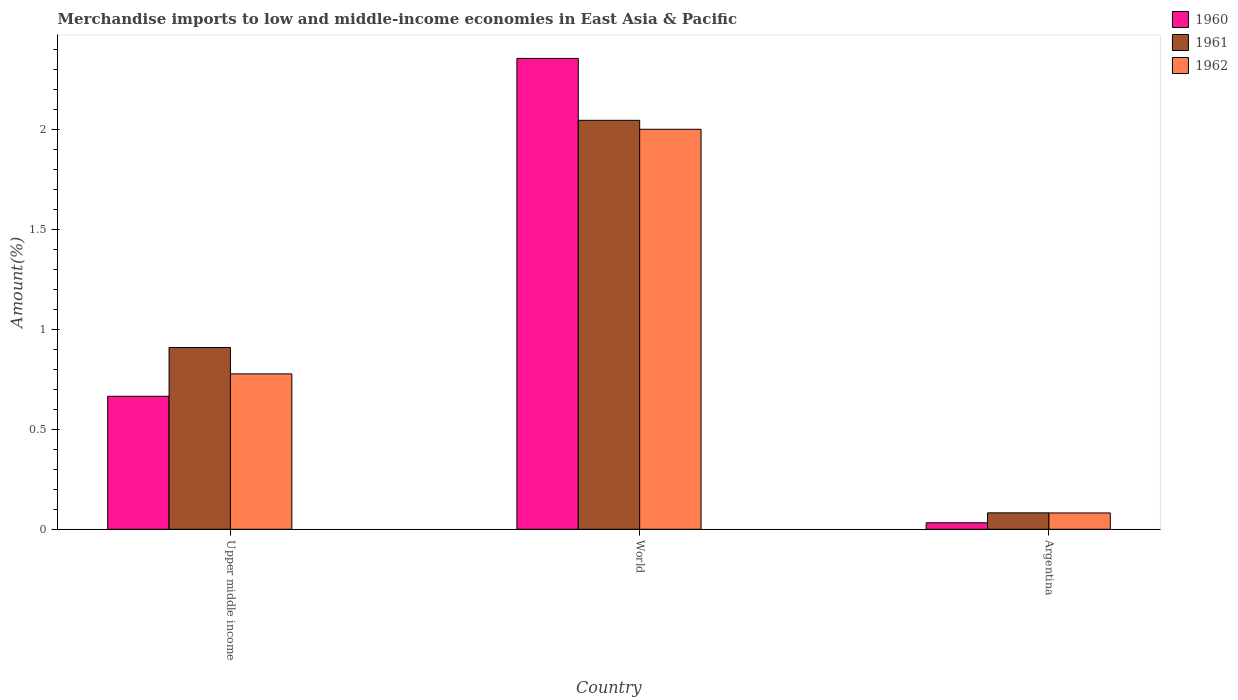How many groups of bars are there?
Provide a succinct answer. 3. Are the number of bars per tick equal to the number of legend labels?
Your answer should be very brief. Yes. What is the percentage of amount earned from merchandise imports in 1961 in World?
Keep it short and to the point. 2.05. Across all countries, what is the maximum percentage of amount earned from merchandise imports in 1961?
Ensure brevity in your answer.  2.05. Across all countries, what is the minimum percentage of amount earned from merchandise imports in 1960?
Provide a succinct answer. 0.03. In which country was the percentage of amount earned from merchandise imports in 1960 maximum?
Keep it short and to the point. World. What is the total percentage of amount earned from merchandise imports in 1960 in the graph?
Provide a succinct answer. 3.05. What is the difference between the percentage of amount earned from merchandise imports in 1961 in Argentina and that in World?
Offer a very short reply. -1.96. What is the difference between the percentage of amount earned from merchandise imports in 1960 in World and the percentage of amount earned from merchandise imports in 1961 in Argentina?
Your answer should be compact. 2.27. What is the average percentage of amount earned from merchandise imports in 1961 per country?
Your answer should be compact. 1.01. What is the difference between the percentage of amount earned from merchandise imports of/in 1962 and percentage of amount earned from merchandise imports of/in 1961 in Upper middle income?
Ensure brevity in your answer.  -0.13. What is the ratio of the percentage of amount earned from merchandise imports in 1961 in Argentina to that in World?
Your answer should be compact. 0.04. Is the percentage of amount earned from merchandise imports in 1962 in Argentina less than that in World?
Make the answer very short. Yes. What is the difference between the highest and the second highest percentage of amount earned from merchandise imports in 1960?
Offer a terse response. -1.69. What is the difference between the highest and the lowest percentage of amount earned from merchandise imports in 1960?
Give a very brief answer. 2.32. In how many countries, is the percentage of amount earned from merchandise imports in 1962 greater than the average percentage of amount earned from merchandise imports in 1962 taken over all countries?
Keep it short and to the point. 1. Is the sum of the percentage of amount earned from merchandise imports in 1961 in Argentina and Upper middle income greater than the maximum percentage of amount earned from merchandise imports in 1962 across all countries?
Offer a terse response. No. What does the 3rd bar from the right in Upper middle income represents?
Your response must be concise. 1960. Are all the bars in the graph horizontal?
Provide a succinct answer. No. How many countries are there in the graph?
Your answer should be very brief. 3. Are the values on the major ticks of Y-axis written in scientific E-notation?
Give a very brief answer. No. Does the graph contain any zero values?
Offer a very short reply. No. Does the graph contain grids?
Ensure brevity in your answer.  No. Where does the legend appear in the graph?
Offer a very short reply. Top right. What is the title of the graph?
Ensure brevity in your answer.  Merchandise imports to low and middle-income economies in East Asia & Pacific. Does "1995" appear as one of the legend labels in the graph?
Make the answer very short. No. What is the label or title of the Y-axis?
Ensure brevity in your answer.  Amount(%). What is the Amount(%) of 1960 in Upper middle income?
Provide a short and direct response. 0.67. What is the Amount(%) in 1961 in Upper middle income?
Provide a succinct answer. 0.91. What is the Amount(%) in 1962 in Upper middle income?
Your answer should be compact. 0.78. What is the Amount(%) in 1960 in World?
Make the answer very short. 2.35. What is the Amount(%) in 1961 in World?
Give a very brief answer. 2.05. What is the Amount(%) in 1962 in World?
Your answer should be compact. 2. What is the Amount(%) in 1960 in Argentina?
Your answer should be very brief. 0.03. What is the Amount(%) in 1961 in Argentina?
Your answer should be compact. 0.08. What is the Amount(%) of 1962 in Argentina?
Give a very brief answer. 0.08. Across all countries, what is the maximum Amount(%) of 1960?
Your response must be concise. 2.35. Across all countries, what is the maximum Amount(%) of 1961?
Provide a short and direct response. 2.05. Across all countries, what is the maximum Amount(%) in 1962?
Your answer should be very brief. 2. Across all countries, what is the minimum Amount(%) of 1960?
Your answer should be compact. 0.03. Across all countries, what is the minimum Amount(%) in 1961?
Give a very brief answer. 0.08. Across all countries, what is the minimum Amount(%) in 1962?
Your response must be concise. 0.08. What is the total Amount(%) of 1960 in the graph?
Your response must be concise. 3.05. What is the total Amount(%) in 1961 in the graph?
Your response must be concise. 3.04. What is the total Amount(%) of 1962 in the graph?
Ensure brevity in your answer.  2.86. What is the difference between the Amount(%) of 1960 in Upper middle income and that in World?
Your answer should be very brief. -1.69. What is the difference between the Amount(%) in 1961 in Upper middle income and that in World?
Give a very brief answer. -1.14. What is the difference between the Amount(%) in 1962 in Upper middle income and that in World?
Provide a succinct answer. -1.22. What is the difference between the Amount(%) in 1960 in Upper middle income and that in Argentina?
Offer a very short reply. 0.63. What is the difference between the Amount(%) in 1961 in Upper middle income and that in Argentina?
Provide a succinct answer. 0.83. What is the difference between the Amount(%) in 1962 in Upper middle income and that in Argentina?
Ensure brevity in your answer.  0.7. What is the difference between the Amount(%) of 1960 in World and that in Argentina?
Offer a very short reply. 2.32. What is the difference between the Amount(%) in 1961 in World and that in Argentina?
Offer a very short reply. 1.96. What is the difference between the Amount(%) of 1962 in World and that in Argentina?
Keep it short and to the point. 1.92. What is the difference between the Amount(%) of 1960 in Upper middle income and the Amount(%) of 1961 in World?
Offer a terse response. -1.38. What is the difference between the Amount(%) of 1960 in Upper middle income and the Amount(%) of 1962 in World?
Your answer should be very brief. -1.34. What is the difference between the Amount(%) in 1961 in Upper middle income and the Amount(%) in 1962 in World?
Keep it short and to the point. -1.09. What is the difference between the Amount(%) in 1960 in Upper middle income and the Amount(%) in 1961 in Argentina?
Your answer should be compact. 0.58. What is the difference between the Amount(%) of 1960 in Upper middle income and the Amount(%) of 1962 in Argentina?
Ensure brevity in your answer.  0.58. What is the difference between the Amount(%) in 1961 in Upper middle income and the Amount(%) in 1962 in Argentina?
Your response must be concise. 0.83. What is the difference between the Amount(%) of 1960 in World and the Amount(%) of 1961 in Argentina?
Keep it short and to the point. 2.27. What is the difference between the Amount(%) in 1960 in World and the Amount(%) in 1962 in Argentina?
Your response must be concise. 2.27. What is the difference between the Amount(%) in 1961 in World and the Amount(%) in 1962 in Argentina?
Offer a very short reply. 1.96. What is the average Amount(%) in 1960 per country?
Provide a succinct answer. 1.02. What is the average Amount(%) of 1961 per country?
Give a very brief answer. 1.01. What is the average Amount(%) of 1962 per country?
Your answer should be compact. 0.95. What is the difference between the Amount(%) of 1960 and Amount(%) of 1961 in Upper middle income?
Your answer should be very brief. -0.24. What is the difference between the Amount(%) in 1960 and Amount(%) in 1962 in Upper middle income?
Your answer should be compact. -0.11. What is the difference between the Amount(%) in 1961 and Amount(%) in 1962 in Upper middle income?
Provide a succinct answer. 0.13. What is the difference between the Amount(%) of 1960 and Amount(%) of 1961 in World?
Keep it short and to the point. 0.31. What is the difference between the Amount(%) of 1960 and Amount(%) of 1962 in World?
Provide a succinct answer. 0.35. What is the difference between the Amount(%) of 1961 and Amount(%) of 1962 in World?
Offer a terse response. 0.04. What is the difference between the Amount(%) of 1960 and Amount(%) of 1961 in Argentina?
Keep it short and to the point. -0.05. What is the difference between the Amount(%) of 1960 and Amount(%) of 1962 in Argentina?
Your answer should be very brief. -0.05. What is the ratio of the Amount(%) in 1960 in Upper middle income to that in World?
Give a very brief answer. 0.28. What is the ratio of the Amount(%) in 1961 in Upper middle income to that in World?
Provide a short and direct response. 0.44. What is the ratio of the Amount(%) of 1962 in Upper middle income to that in World?
Ensure brevity in your answer.  0.39. What is the ratio of the Amount(%) in 1960 in Upper middle income to that in Argentina?
Make the answer very short. 20.41. What is the ratio of the Amount(%) in 1961 in Upper middle income to that in Argentina?
Your response must be concise. 11.06. What is the ratio of the Amount(%) of 1962 in Upper middle income to that in Argentina?
Your answer should be compact. 9.52. What is the ratio of the Amount(%) in 1960 in World to that in Argentina?
Offer a terse response. 72.25. What is the ratio of the Amount(%) of 1961 in World to that in Argentina?
Ensure brevity in your answer.  24.89. What is the ratio of the Amount(%) of 1962 in World to that in Argentina?
Your answer should be very brief. 24.5. What is the difference between the highest and the second highest Amount(%) of 1960?
Offer a terse response. 1.69. What is the difference between the highest and the second highest Amount(%) in 1961?
Keep it short and to the point. 1.14. What is the difference between the highest and the second highest Amount(%) in 1962?
Your answer should be compact. 1.22. What is the difference between the highest and the lowest Amount(%) in 1960?
Make the answer very short. 2.32. What is the difference between the highest and the lowest Amount(%) in 1961?
Your response must be concise. 1.96. What is the difference between the highest and the lowest Amount(%) in 1962?
Provide a short and direct response. 1.92. 